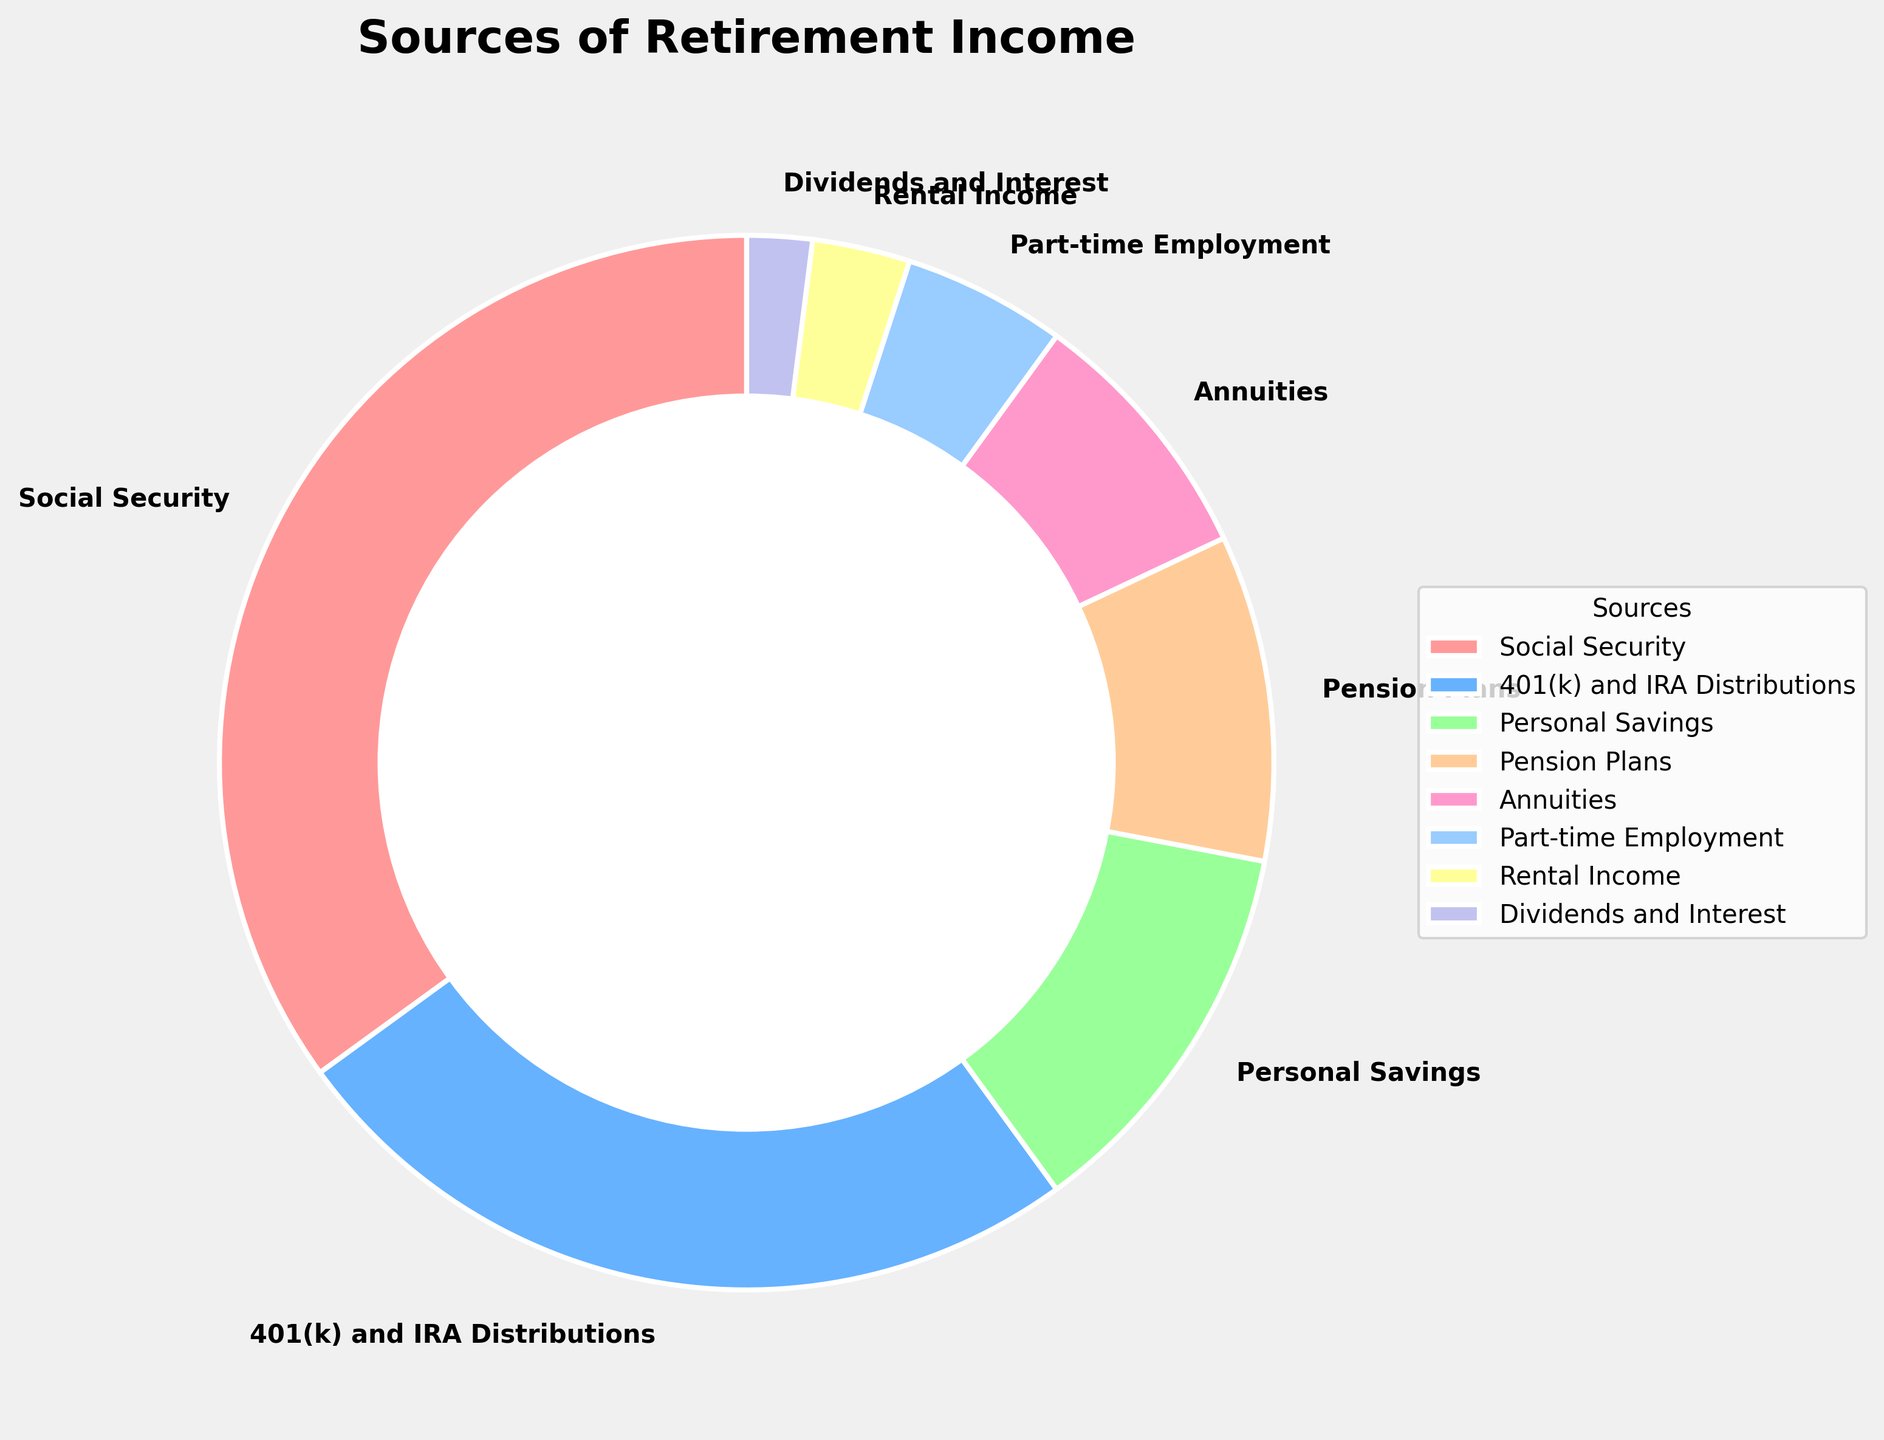Which source accounts for the largest percentage of retirement income? The pie chart shows that Social Security has the largest segment with 35%, making it the largest source of retirement income.
Answer: Social Security Which two sources of retirement income have the closest percentages? By comparing the percentages in the pie chart, 401(k) and IRA Distributions (25%) and Personal Savings (12%) combined are closest to the percentage of Social Security (35%). Another close pair is Pension Plans (10%) and Annuities (8%).
Answer: Pension Plans and Annuities How does the percentage of income from part-time employment compare to rental income? The percentage of income from part-time employment is 5%, while rental income is 3%. Part-time employment is higher by 2 percentage points.
Answer: Part-time employment is higher Which sources of retirement income together make up more than half of the total income? Adding up the percentages of the top sources: Social Security (35%) + 401(k) and IRA Distributions (25%) = 60%, which is more than half.
Answer: Social Security and 401(k) and IRA Distributions What is the total percentage contribution from Annuities, Part-time Employment, and Dividends and Interest? Summing the percentages: Annuities (8%) + Part-time Employment (5%) + Dividends and Interest (2%) = 15%.
Answer: 15% What is the difference in percentage between the largest and smallest sources of retirement income? The largest source is Social Security at 35%, and the smallest is Dividends and Interest at 2%. The difference is 35% - 2% = 33%.
Answer: 33% Which sources combined account for less than one-fourth of the total retirement income? Summing the smaller sources: Personal Savings (12%) + Pension Plans (10%) + Annuities (8%) + Part-time Employment (5%) + Rental Income (3%) + Dividends and Interest (2%). The total is 40%, and since combinations of three or less can sum up to less than a fourth, the possible combinations are: Rental Income + Dividends and Interest, Part-time Employment + Rental Income, Dividends and Interest, and various other pairs, but each combination must remain below 25%.
Answer: Part-time Employment, Rental Income, and Dividends and Interest What is the combined percentage of 401(k) and IRA Distributions, Personal Savings, and Pension Plans? Adding 401(k) and IRA Distributions (25%) + Personal Savings (12%) + Pension Plans (10%) gives a total of 47%.
Answer: 47% What is the least common source of retirement income according to the chart? Looking at the smallest segment on the pie chart, Dividends and Interest have the smallest percentage at 2%.
Answer: Dividends and Interest Which source of retirement income has a percentage that is a little more than one-third of Social Security's percentage? One-third of Social Security's percentage (35%) is about 11.67%, slightly more than this value is Personal Savings at 12%.
Answer: Personal Savings 